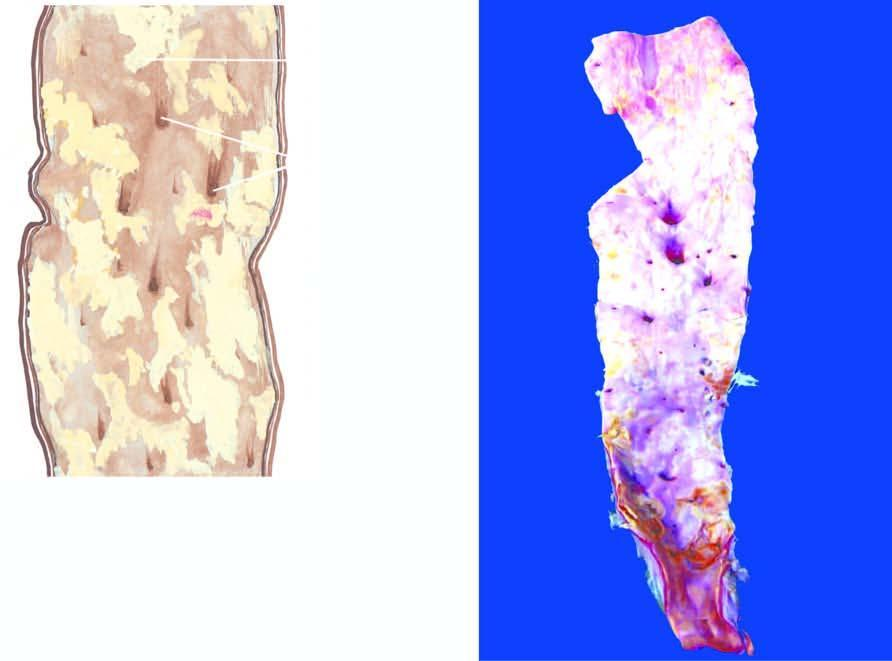does these layers rest show a variety of atheromatous lesions?
Answer the question using a single word or phrase. No 